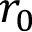<formula> <loc_0><loc_0><loc_500><loc_500>r _ { 0 }</formula> 